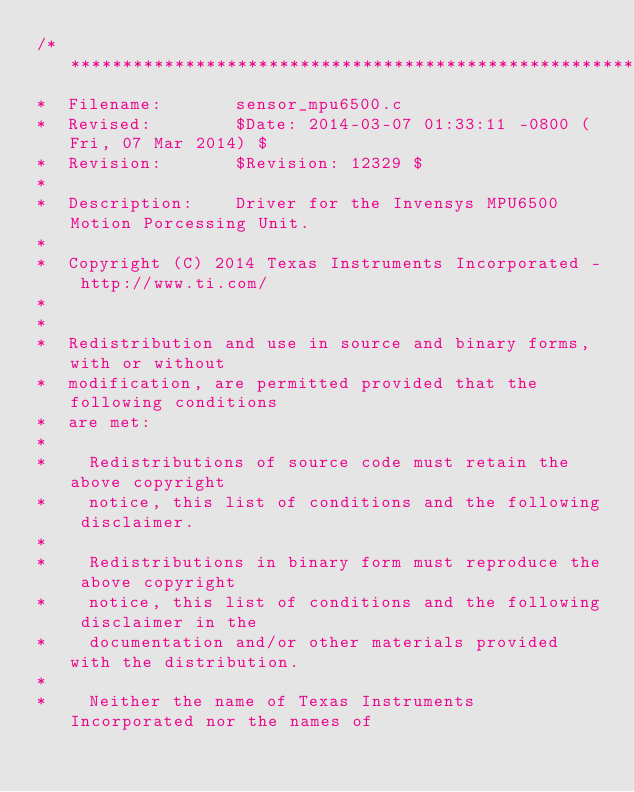<code> <loc_0><loc_0><loc_500><loc_500><_C_>/******************************************************************************
*  Filename:       sensor_mpu6500.c
*  Revised:        $Date: 2014-03-07 01:33:11 -0800 (Fri, 07 Mar 2014) $
*  Revision:       $Revision: 12329 $
*
*  Description:    Driver for the Invensys MPU6500 Motion Porcessing Unit.
*
*  Copyright (C) 2014 Texas Instruments Incorporated - http://www.ti.com/
*
*
*  Redistribution and use in source and binary forms, with or without
*  modification, are permitted provided that the following conditions
*  are met:
*
*    Redistributions of source code must retain the above copyright
*    notice, this list of conditions and the following disclaimer.
*
*    Redistributions in binary form must reproduce the above copyright
*    notice, this list of conditions and the following disclaimer in the
*    documentation and/or other materials provided with the distribution.
*
*    Neither the name of Texas Instruments Incorporated nor the names of</code> 